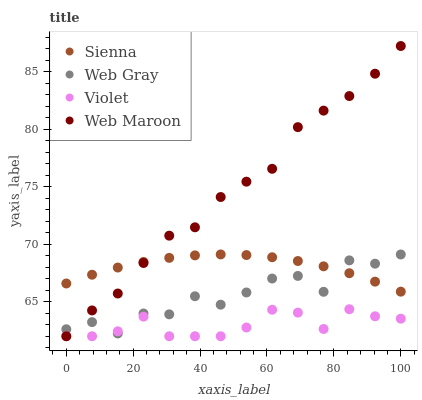Does Violet have the minimum area under the curve?
Answer yes or no. Yes. Does Web Maroon have the maximum area under the curve?
Answer yes or no. Yes. Does Web Gray have the minimum area under the curve?
Answer yes or no. No. Does Web Gray have the maximum area under the curve?
Answer yes or no. No. Is Sienna the smoothest?
Answer yes or no. Yes. Is Web Gray the roughest?
Answer yes or no. Yes. Is Web Maroon the smoothest?
Answer yes or no. No. Is Web Maroon the roughest?
Answer yes or no. No. Does Web Maroon have the lowest value?
Answer yes or no. Yes. Does Web Gray have the lowest value?
Answer yes or no. No. Does Web Maroon have the highest value?
Answer yes or no. Yes. Does Web Gray have the highest value?
Answer yes or no. No. Is Violet less than Sienna?
Answer yes or no. Yes. Is Sienna greater than Violet?
Answer yes or no. Yes. Does Web Maroon intersect Web Gray?
Answer yes or no. Yes. Is Web Maroon less than Web Gray?
Answer yes or no. No. Is Web Maroon greater than Web Gray?
Answer yes or no. No. Does Violet intersect Sienna?
Answer yes or no. No. 